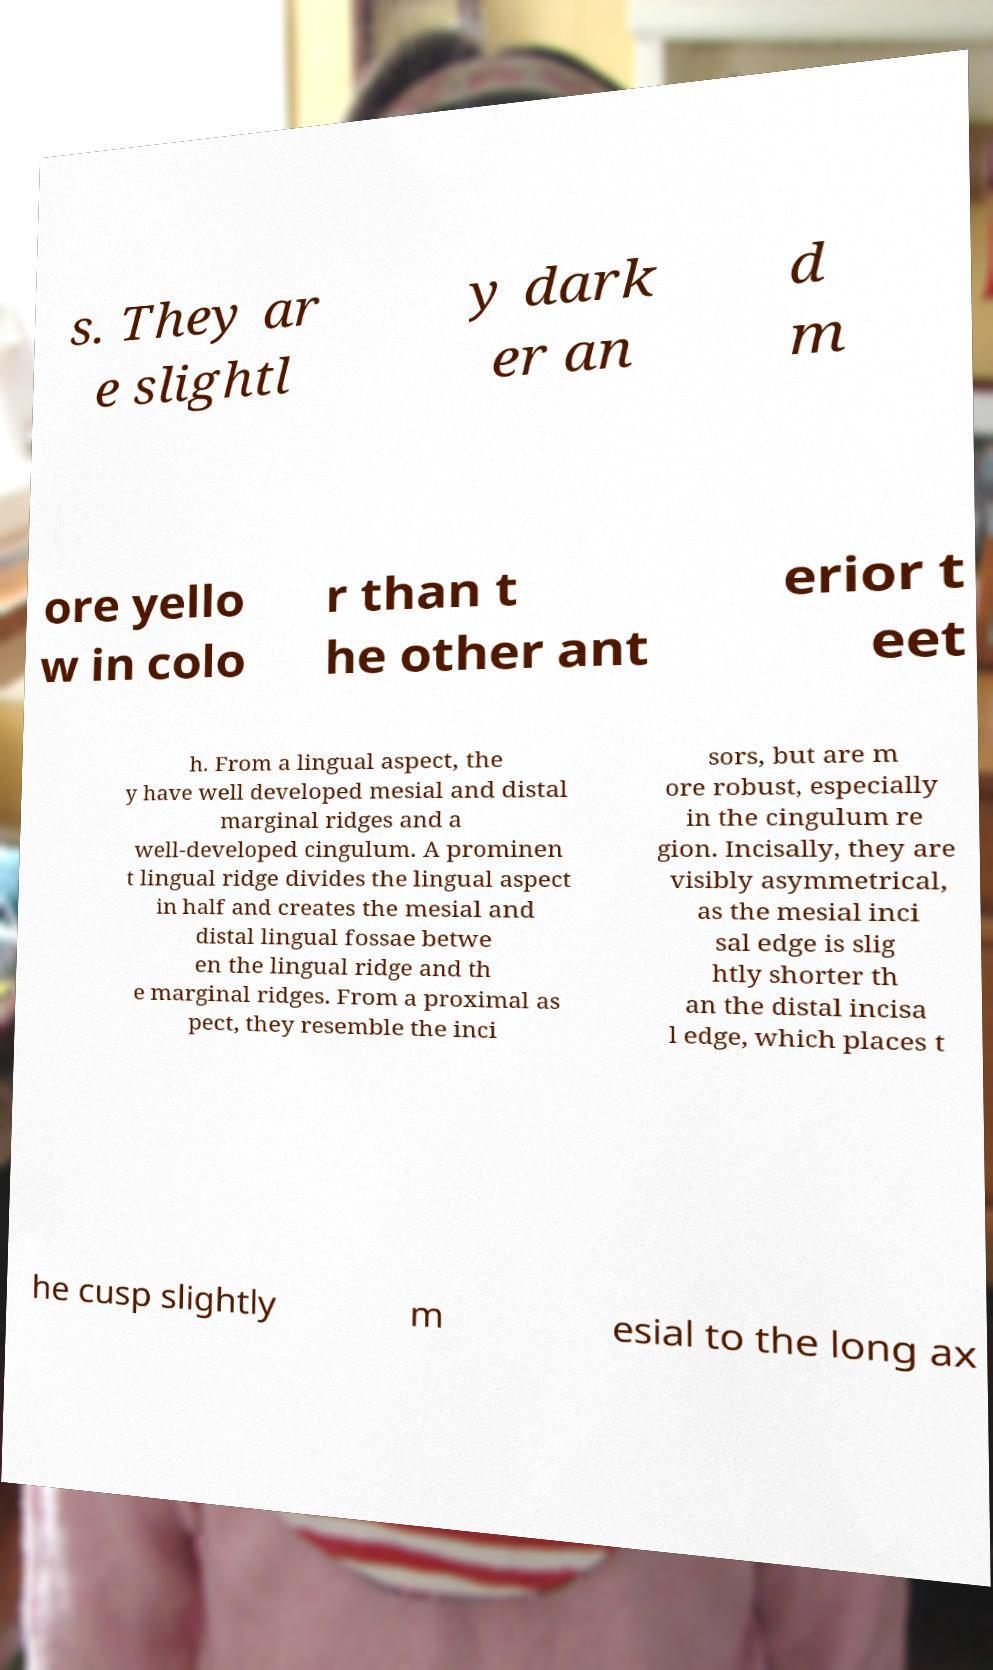There's text embedded in this image that I need extracted. Can you transcribe it verbatim? s. They ar e slightl y dark er an d m ore yello w in colo r than t he other ant erior t eet h. From a lingual aspect, the y have well developed mesial and distal marginal ridges and a well-developed cingulum. A prominen t lingual ridge divides the lingual aspect in half and creates the mesial and distal lingual fossae betwe en the lingual ridge and th e marginal ridges. From a proximal as pect, they resemble the inci sors, but are m ore robust, especially in the cingulum re gion. Incisally, they are visibly asymmetrical, as the mesial inci sal edge is slig htly shorter th an the distal incisa l edge, which places t he cusp slightly m esial to the long ax 